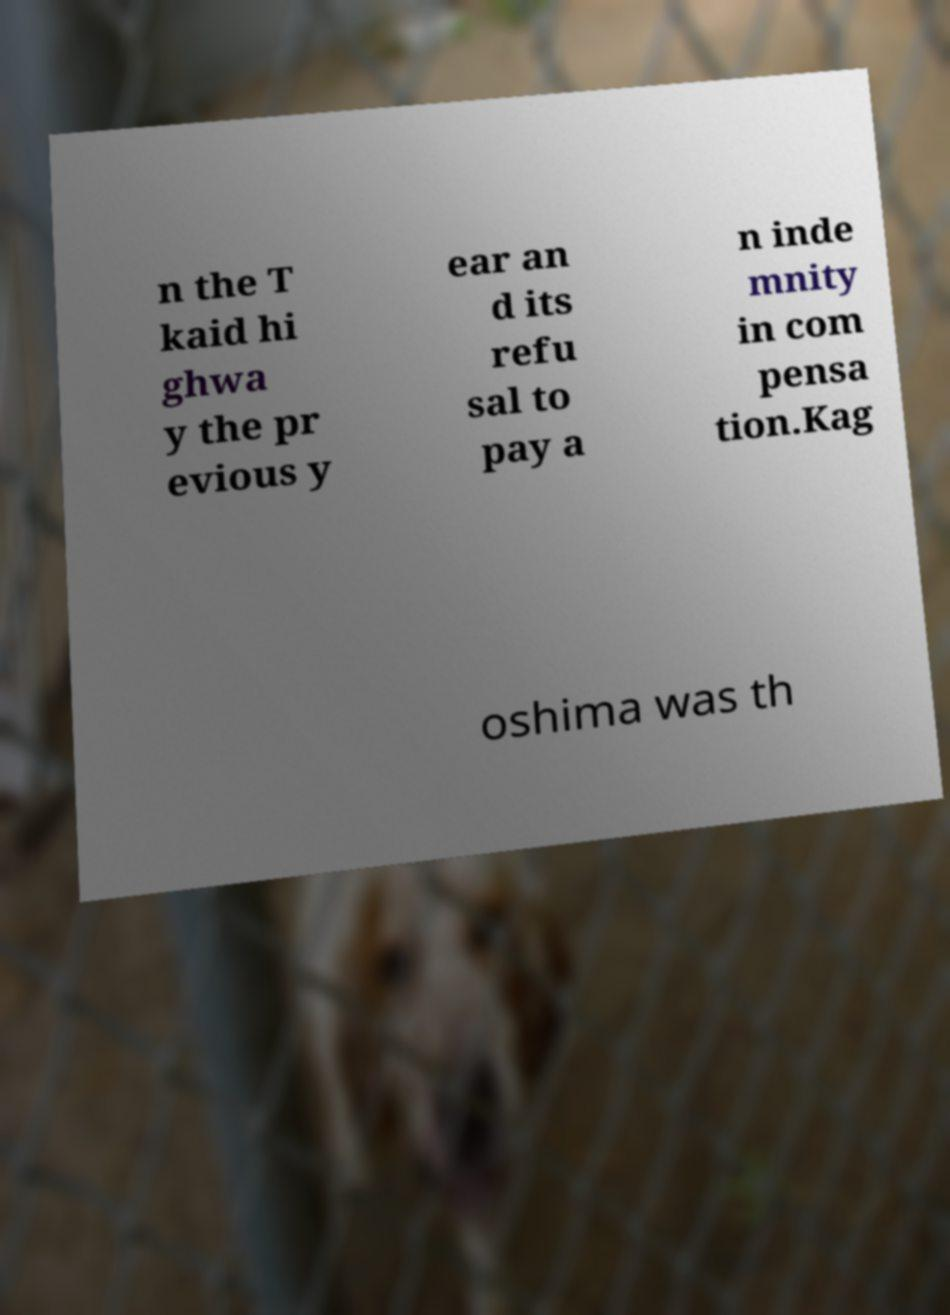Please read and relay the text visible in this image. What does it say? n the T kaid hi ghwa y the pr evious y ear an d its refu sal to pay a n inde mnity in com pensa tion.Kag oshima was th 